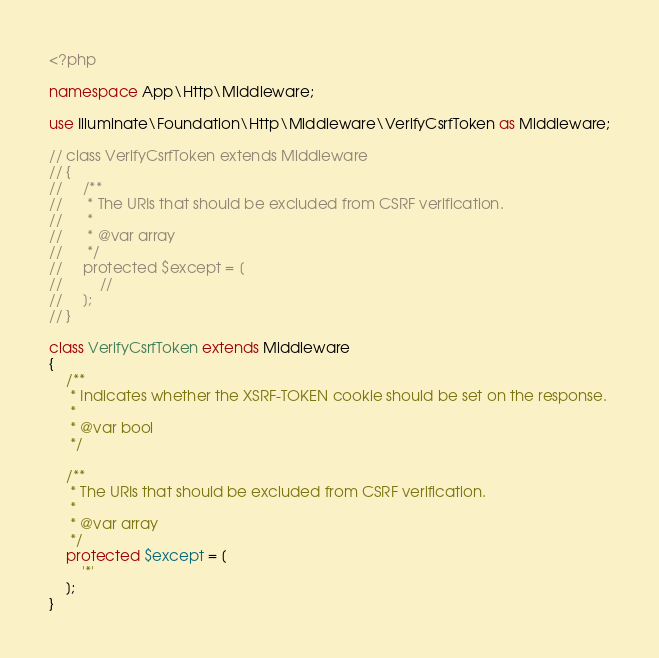Convert code to text. <code><loc_0><loc_0><loc_500><loc_500><_PHP_><?php

namespace App\Http\Middleware;

use Illuminate\Foundation\Http\Middleware\VerifyCsrfToken as Middleware;

// class VerifyCsrfToken extends Middleware
// {
//     /**
//      * The URIs that should be excluded from CSRF verification.
//      *
//      * @var array
//      */
//     protected $except = [
//         //
//     ];
// }

class VerifyCsrfToken extends Middleware
{
    /**
     * Indicates whether the XSRF-TOKEN cookie should be set on the response.
     *
     * @var bool
     */

    /**
     * The URIs that should be excluded from CSRF verification.
     *
     * @var array
     */
    protected $except = [
        '*'
    ];
}</code> 